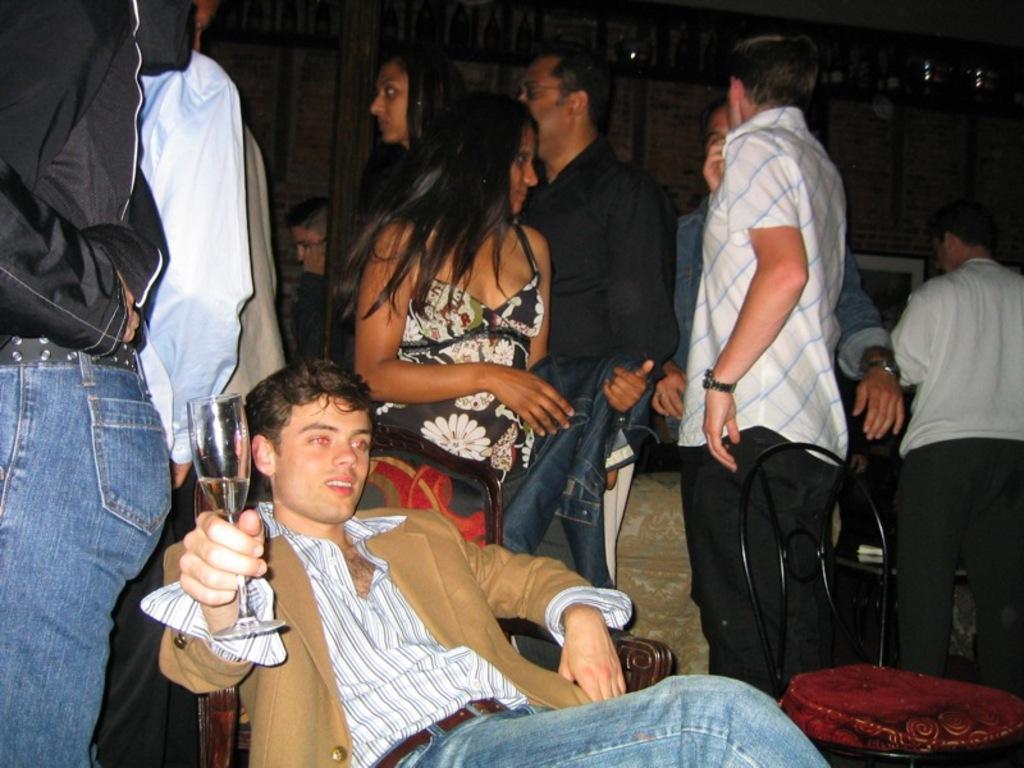Can you describe this image briefly? In the foreground of this image, there is a man sitting on the chair holding a glass. In the background, there are persons standing, a chair, a sofa and it seems like there is a wall in the background. 